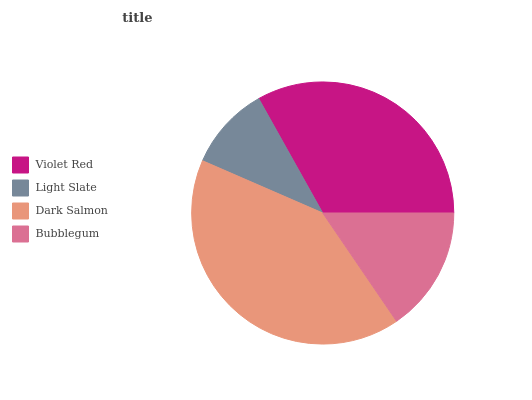Is Light Slate the minimum?
Answer yes or no. Yes. Is Dark Salmon the maximum?
Answer yes or no. Yes. Is Dark Salmon the minimum?
Answer yes or no. No. Is Light Slate the maximum?
Answer yes or no. No. Is Dark Salmon greater than Light Slate?
Answer yes or no. Yes. Is Light Slate less than Dark Salmon?
Answer yes or no. Yes. Is Light Slate greater than Dark Salmon?
Answer yes or no. No. Is Dark Salmon less than Light Slate?
Answer yes or no. No. Is Violet Red the high median?
Answer yes or no. Yes. Is Bubblegum the low median?
Answer yes or no. Yes. Is Light Slate the high median?
Answer yes or no. No. Is Light Slate the low median?
Answer yes or no. No. 